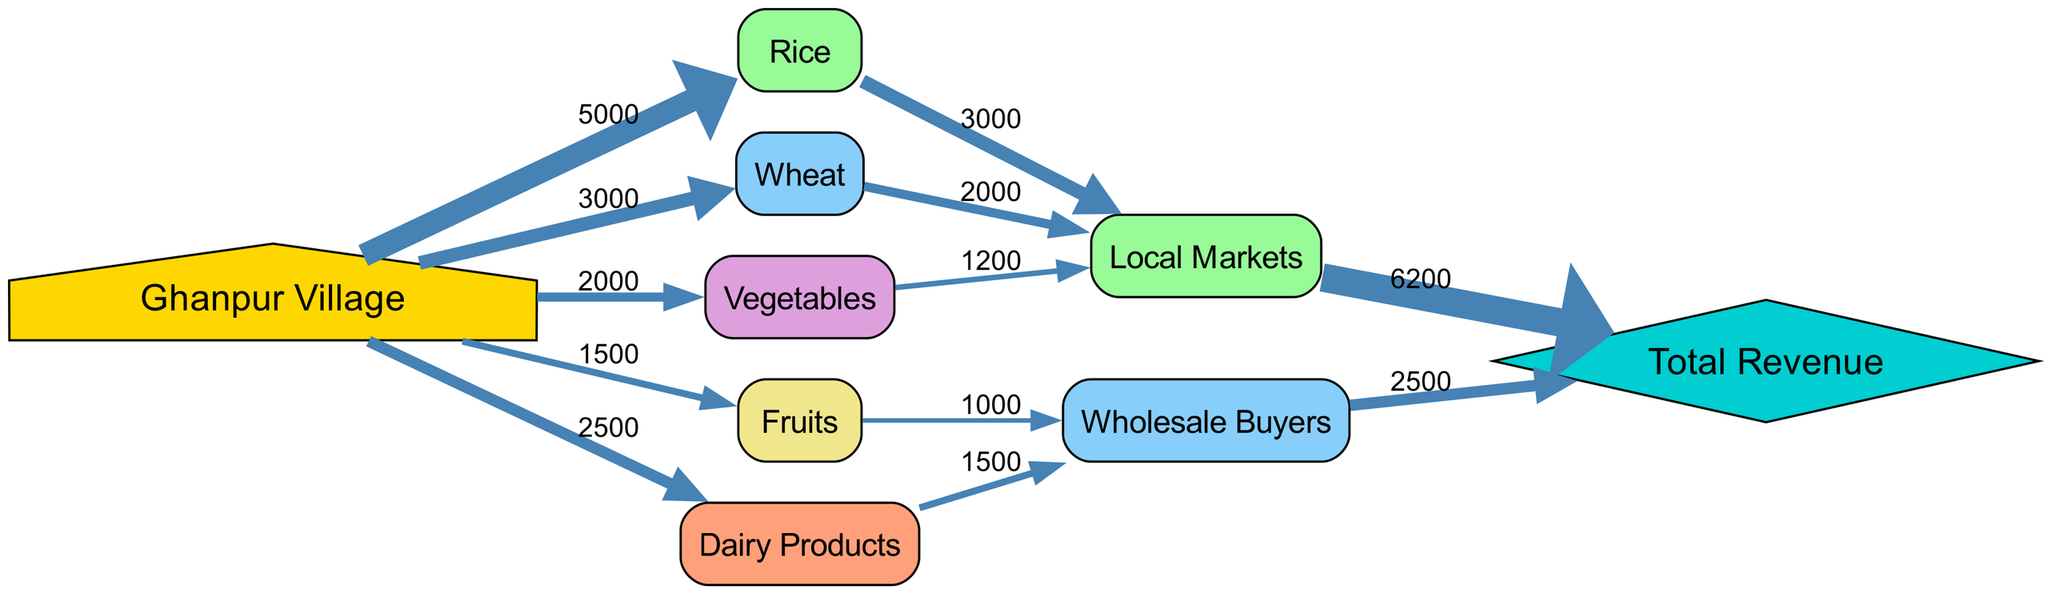What is the total quantity of rice sold from Ghanpur Village? The diagram shows a link from "Ghanpur Village" to "Rice" with a value of 5000, indicating that this is the quantity of rice sold.
Answer: 5000 What is the value of the link from Wheat to Local Markets? From the diagram, the value of the link from "Wheat" to "Local Markets" is 2000, which represents the quantity of wheat sold to local markets.
Answer: 2000 How many types of agricultural produce are shown in the diagram? The diagram lists five types of agricultural produce: Rice, Wheat, Vegetables, Fruits, and Dairy Products, meaning there are a total of five types.
Answer: 5 How much revenue is generated from Local Markets? The diagram indicates that the total revenue generated from the "Local Markets" is represented as 6200, based on the connections shown in the chart.
Answer: 6200 Which product generates more revenue: Fruits or Dairy Products? The diagram shows that "Fruits" link to "Wholesale Buyers" generates a value of 1000, while "Dairy Products" link generates a value of 1500. Since 1500 > 1000, Dairy Products generate more revenue.
Answer: Dairy Products What is the relationship between Ghanpur Village and Total Revenue? The diagram illustrates that Ghanpur Village is the starting point, and its agricultural produce links to different markets, which eventually contribute to the overall "Total Revenue". The flow indicates that the sales from various products culminate into total revenue.
Answer: Contribution How much revenue comes from Wholesale Buyers? The diagram shows that the link from "Wholesale Buyers" to "Total Revenue" has a value of 2500, indicating this is the revenue attribute from wholesale buyers.
Answer: 2500 Which product has the least quantity sold? The diagram shows "Fruits" has the least quantity sold compared to other products, with a value of 1500, the smallest among other links from Ghanpur Village.
Answer: Fruits What is the overall connection flow from the village to Total Revenue? The diagram depicts that productions sold from Ghanpur Village flows through various links to Local Markets and Wholesale Buyers, all contributing to the "Total Revenue" showing the entire sales distribution process from production to revenue generation.
Answer: Flow 